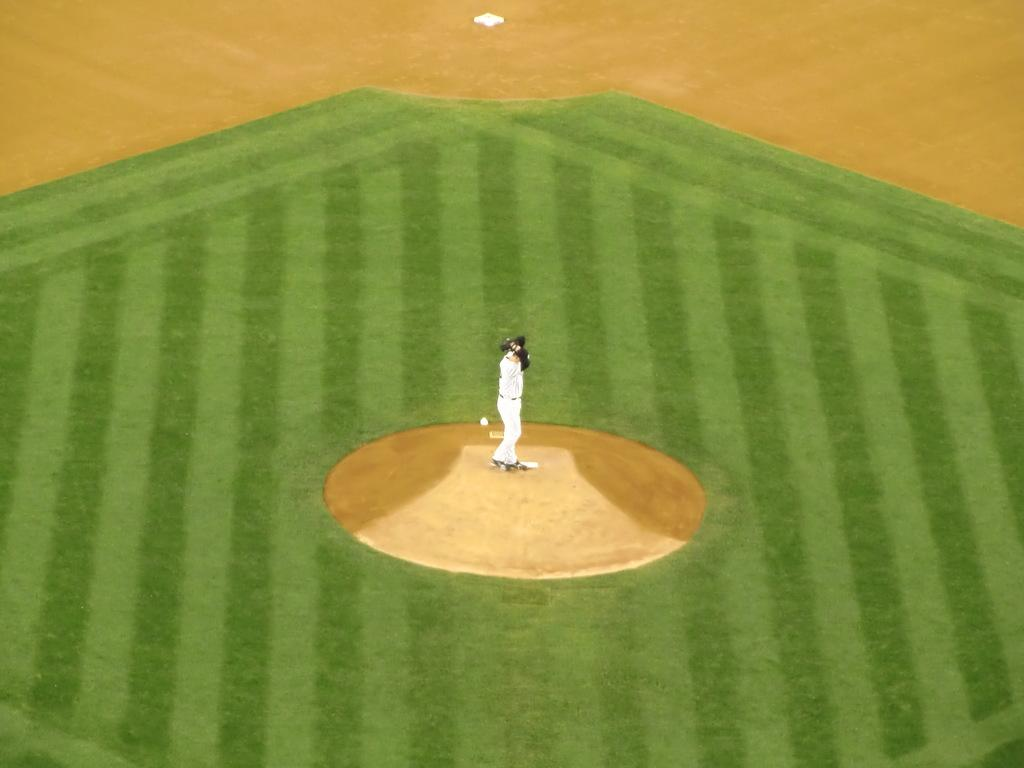What is the main subject of the image? The main subject of the image is a person standing. What is the person standing on? The person is standing on the ground. What type of vegetation is visible in the image? There is grass visible in the image. What type of underwear is the person wearing in the image? There is no information about the person's underwear in the image. How many people are present in the image? The image only shows one person standing. What type of seasoning is visible in the image? There is no seasoning, such as salt, present in the image. 